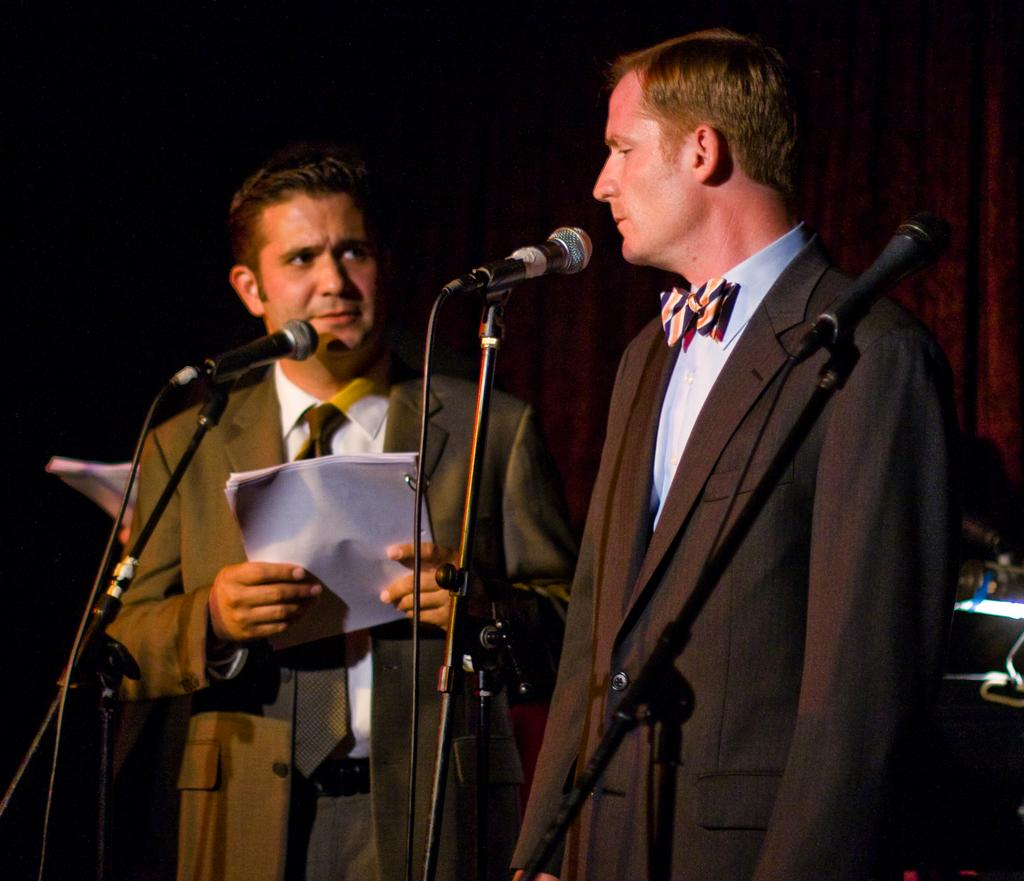How many people are in the image? There are two persons standing in the image. What objects are in front of the two persons? There are three microphones in front of the two persons. What are the two persons wearing? Both persons are wearing suits. Can you describe the person holding something in the image? There is a person holding some papers in the image. What type of circle is visible on the linen in the image? There is no circle or linen present in the image. What is the reaction of the two persons when they receive the surprise in the image? There is no surprise or reaction to a surprise in the image. 